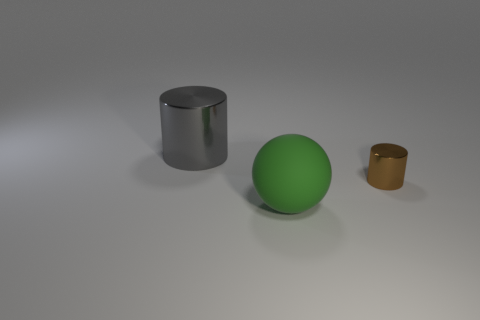Add 3 green rubber balls. How many objects exist? 6 Subtract 0 gray balls. How many objects are left? 3 Subtract all spheres. How many objects are left? 2 Subtract all tiny cylinders. Subtract all big objects. How many objects are left? 0 Add 3 tiny brown shiny cylinders. How many tiny brown shiny cylinders are left? 4 Add 2 big green balls. How many big green balls exist? 3 